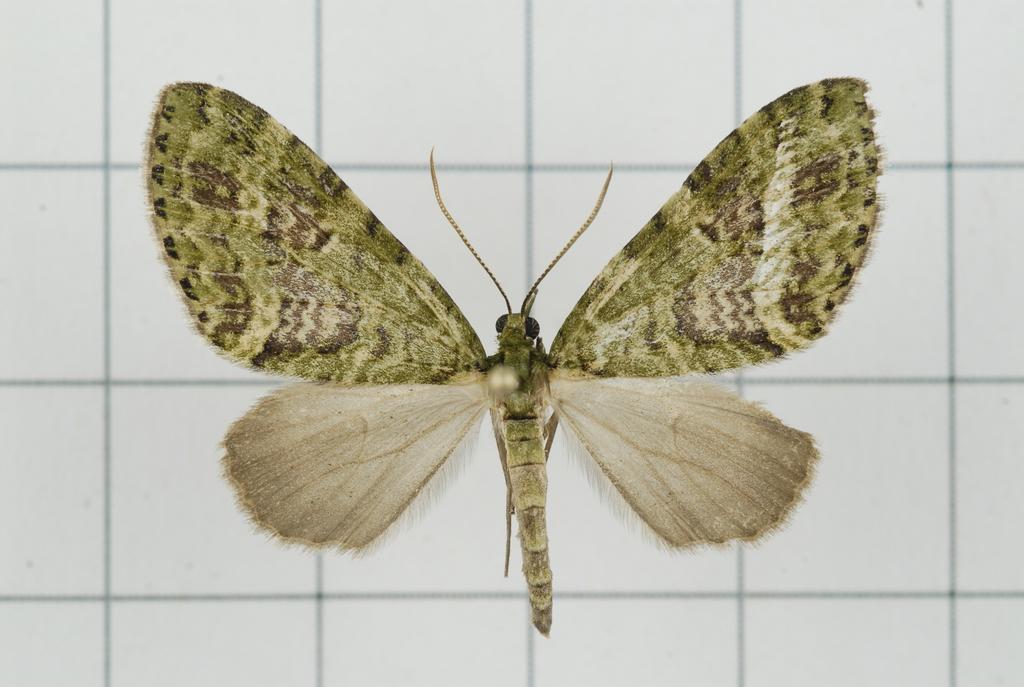Please provide a concise description of this image. In this picture we can see a fly with green color wings and in the background we can see a floor. 